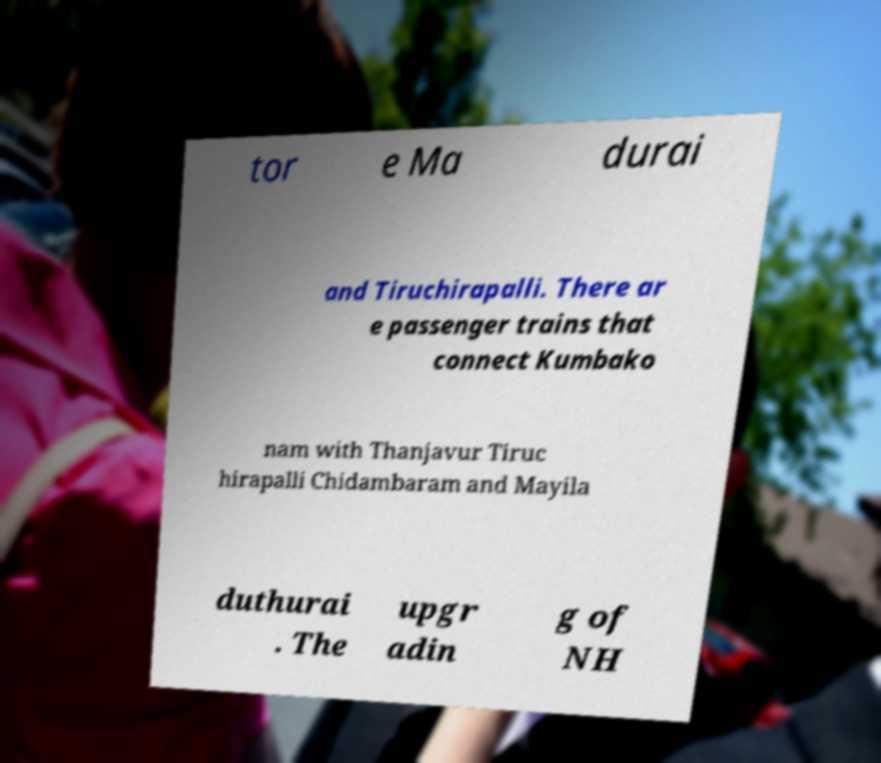For documentation purposes, I need the text within this image transcribed. Could you provide that? tor e Ma durai and Tiruchirapalli. There ar e passenger trains that connect Kumbako nam with Thanjavur Tiruc hirapalli Chidambaram and Mayila duthurai . The upgr adin g of NH 